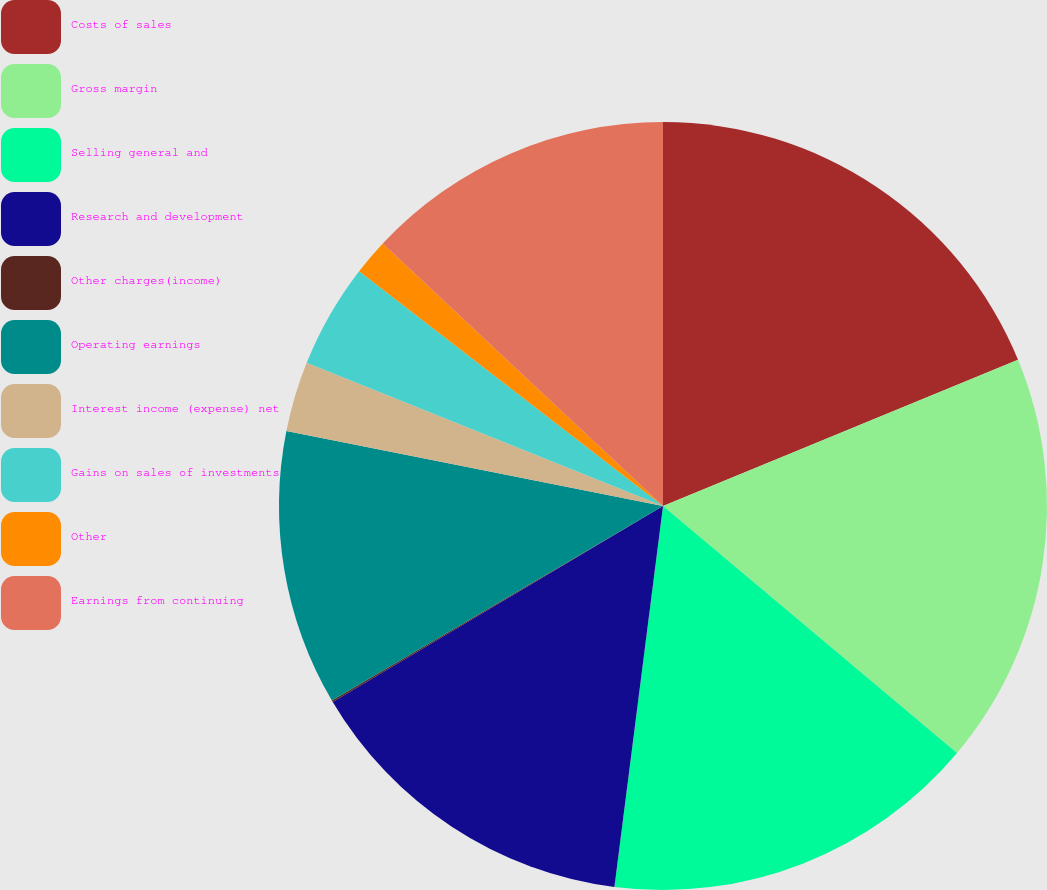Convert chart to OTSL. <chart><loc_0><loc_0><loc_500><loc_500><pie_chart><fcel>Costs of sales<fcel>Gross margin<fcel>Selling general and<fcel>Research and development<fcel>Other charges(income)<fcel>Operating earnings<fcel>Interest income (expense) net<fcel>Gains on sales of investments<fcel>Other<fcel>Earnings from continuing<nl><fcel>18.78%<fcel>17.34%<fcel>15.9%<fcel>14.46%<fcel>0.07%<fcel>11.58%<fcel>2.95%<fcel>4.39%<fcel>1.51%<fcel>13.02%<nl></chart> 